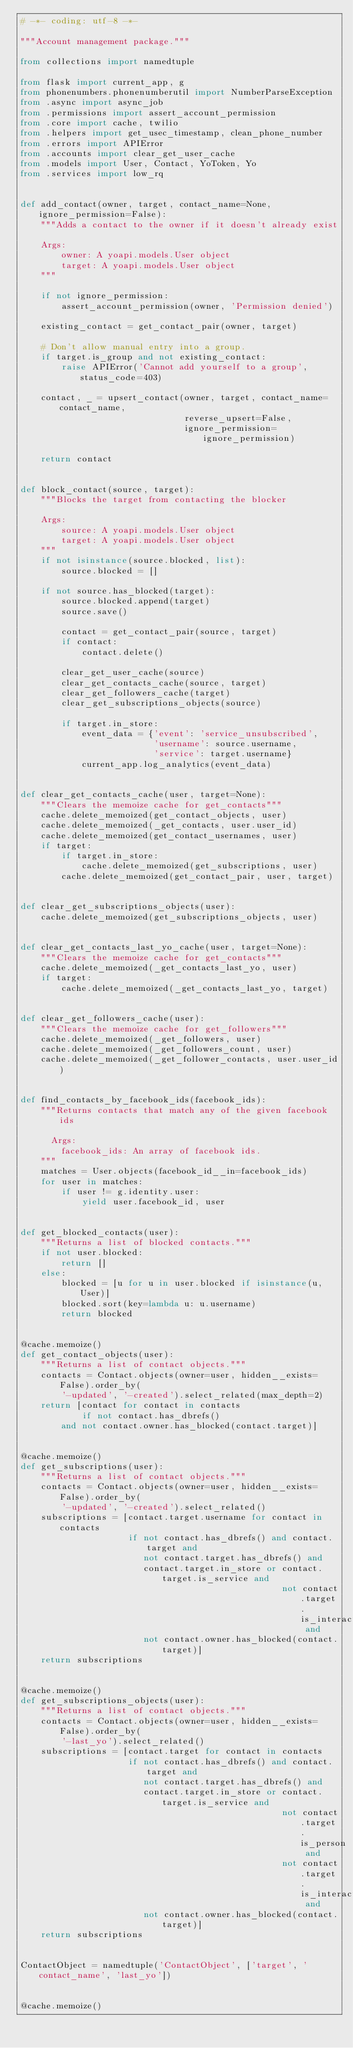Convert code to text. <code><loc_0><loc_0><loc_500><loc_500><_Python_># -*- coding: utf-8 -*-

"""Account management package."""

from collections import namedtuple

from flask import current_app, g
from phonenumbers.phonenumberutil import NumberParseException
from .async import async_job
from .permissions import assert_account_permission
from .core import cache, twilio
from .helpers import get_usec_timestamp, clean_phone_number
from .errors import APIError
from .accounts import clear_get_user_cache
from .models import User, Contact, YoToken, Yo
from .services import low_rq


def add_contact(owner, target, contact_name=None, ignore_permission=False):
    """Adds a contact to the owner if it doesn't already exist

    Args:
        owner: A yoapi.models.User object
        target: A yoapi.models.User object
    """

    if not ignore_permission:
        assert_account_permission(owner, 'Permission denied')

    existing_contact = get_contact_pair(owner, target)

    # Don't allow manual entry into a group.
    if target.is_group and not existing_contact:
        raise APIError('Cannot add yourself to a group', status_code=403)

    contact, _ = upsert_contact(owner, target, contact_name=contact_name,
                                reverse_upsert=False,
                                ignore_permission=ignore_permission)

    return contact


def block_contact(source, target):
    """Blocks the target from contacting the blocker

    Args:
        source: A yoapi.models.User object
        target: A yoapi.models.User object
    """
    if not isinstance(source.blocked, list):
        source.blocked = []

    if not source.has_blocked(target):
        source.blocked.append(target)
        source.save()

        contact = get_contact_pair(source, target)
        if contact:
            contact.delete()

        clear_get_user_cache(source)
        clear_get_contacts_cache(source, target)
        clear_get_followers_cache(target)
        clear_get_subscriptions_objects(source)

        if target.in_store:
            event_data = {'event': 'service_unsubscribed',
                          'username': source.username,
                          'service': target.username}
            current_app.log_analytics(event_data)


def clear_get_contacts_cache(user, target=None):
    """Clears the memoize cache for get_contacts"""
    cache.delete_memoized(get_contact_objects, user)
    cache.delete_memoized(_get_contacts, user.user_id)
    cache.delete_memoized(get_contact_usernames, user)
    if target:
        if target.in_store:
            cache.delete_memoized(get_subscriptions, user)
        cache.delete_memoized(get_contact_pair, user, target)


def clear_get_subscriptions_objects(user):
    cache.delete_memoized(get_subscriptions_objects, user)


def clear_get_contacts_last_yo_cache(user, target=None):
    """Clears the memoize cache for get_contacts"""
    cache.delete_memoized(_get_contacts_last_yo, user)
    if target:
        cache.delete_memoized(_get_contacts_last_yo, target)


def clear_get_followers_cache(user):
    """Clears the memoize cache for get_followers"""
    cache.delete_memoized(_get_followers, user)
    cache.delete_memoized(_get_followers_count, user)
    cache.delete_memoized(_get_follower_contacts, user.user_id)


def find_contacts_by_facebook_ids(facebook_ids):
    """Returns contacts that match any of the given facebook ids

      Args:
        facebook_ids: An array of facebook ids.
    """
    matches = User.objects(facebook_id__in=facebook_ids)
    for user in matches:
        if user != g.identity.user:
            yield user.facebook_id, user


def get_blocked_contacts(user):
    """Returns a list of blocked contacts."""
    if not user.blocked:
        return []
    else:
        blocked = [u for u in user.blocked if isinstance(u, User)]
        blocked.sort(key=lambda u: u.username)
        return blocked


@cache.memoize()
def get_contact_objects(user):
    """Returns a list of contact objects."""
    contacts = Contact.objects(owner=user, hidden__exists=False).order_by(
        '-updated', '-created').select_related(max_depth=2)
    return [contact for contact in contacts
            if not contact.has_dbrefs()
        and not contact.owner.has_blocked(contact.target)]


@cache.memoize()
def get_subscriptions(user):
    """Returns a list of contact objects."""
    contacts = Contact.objects(owner=user, hidden__exists=False).order_by(
        '-updated', '-created').select_related()
    subscriptions = [contact.target.username for contact in contacts
                     if not contact.has_dbrefs() and contact.target and
                        not contact.target.has_dbrefs() and
                        contact.target.in_store or contact.target.is_service and
                                                   not contact.target.is_interactive and
                        not contact.owner.has_blocked(contact.target)]
    return subscriptions


@cache.memoize()
def get_subscriptions_objects(user):
    """Returns a list of contact objects."""
    contacts = Contact.objects(owner=user, hidden__exists=False).order_by(
        '-last_yo').select_related()
    subscriptions = [contact.target for contact in contacts
                     if not contact.has_dbrefs() and contact.target and
                        not contact.target.has_dbrefs() and
                        contact.target.in_store or contact.target.is_service and
                                                   not contact.target.is_person and
                                                   not contact.target.is_interactive and
                        not contact.owner.has_blocked(contact.target)]
    return subscriptions


ContactObject = namedtuple('ContactObject', ['target', 'contact_name', 'last_yo'])


@cache.memoize()</code> 